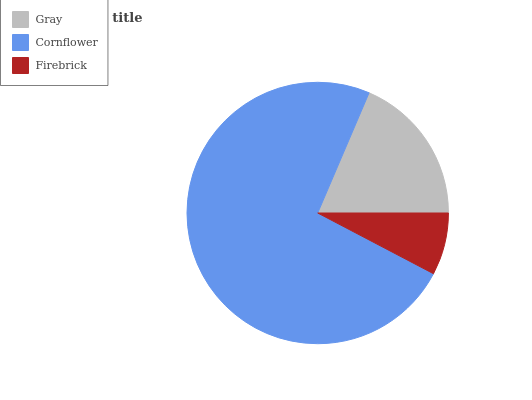Is Firebrick the minimum?
Answer yes or no. Yes. Is Cornflower the maximum?
Answer yes or no. Yes. Is Cornflower the minimum?
Answer yes or no. No. Is Firebrick the maximum?
Answer yes or no. No. Is Cornflower greater than Firebrick?
Answer yes or no. Yes. Is Firebrick less than Cornflower?
Answer yes or no. Yes. Is Firebrick greater than Cornflower?
Answer yes or no. No. Is Cornflower less than Firebrick?
Answer yes or no. No. Is Gray the high median?
Answer yes or no. Yes. Is Gray the low median?
Answer yes or no. Yes. Is Firebrick the high median?
Answer yes or no. No. Is Cornflower the low median?
Answer yes or no. No. 